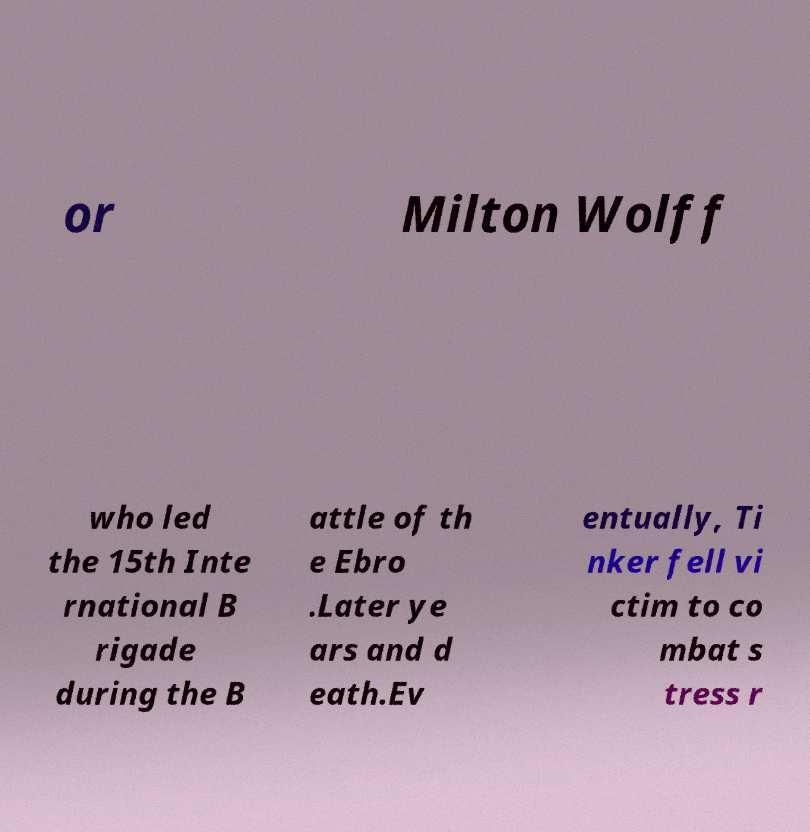For documentation purposes, I need the text within this image transcribed. Could you provide that? or Milton Wolff who led the 15th Inte rnational B rigade during the B attle of th e Ebro .Later ye ars and d eath.Ev entually, Ti nker fell vi ctim to co mbat s tress r 